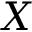Convert formula to latex. <formula><loc_0><loc_0><loc_500><loc_500>X</formula> 